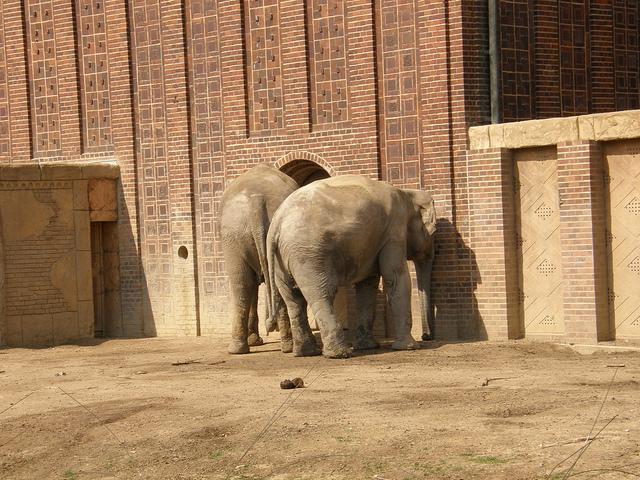How many elephants are there?
Concise answer only. 2. Are they going inside?
Give a very brief answer. No. Are there any windows on the building?
Give a very brief answer. No. 